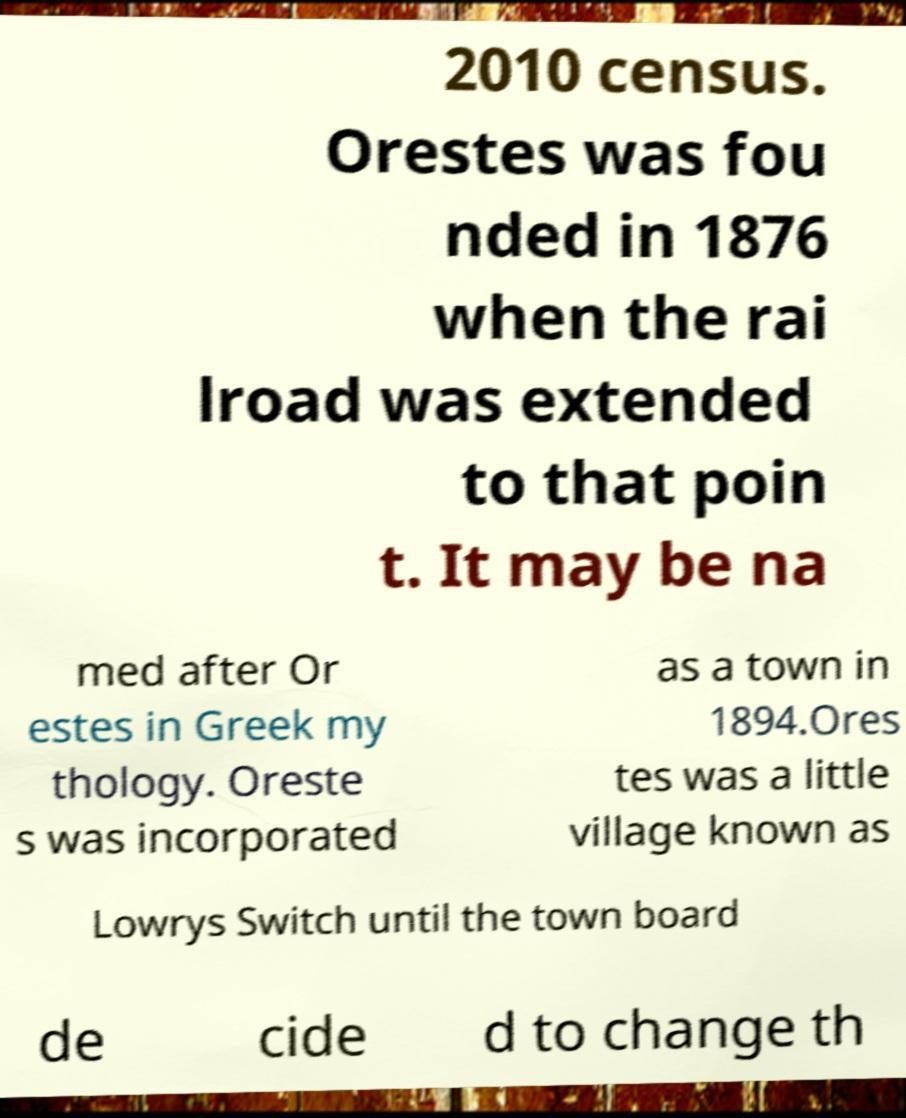I need the written content from this picture converted into text. Can you do that? 2010 census. Orestes was fou nded in 1876 when the rai lroad was extended to that poin t. It may be na med after Or estes in Greek my thology. Oreste s was incorporated as a town in 1894.Ores tes was a little village known as Lowrys Switch until the town board de cide d to change th 